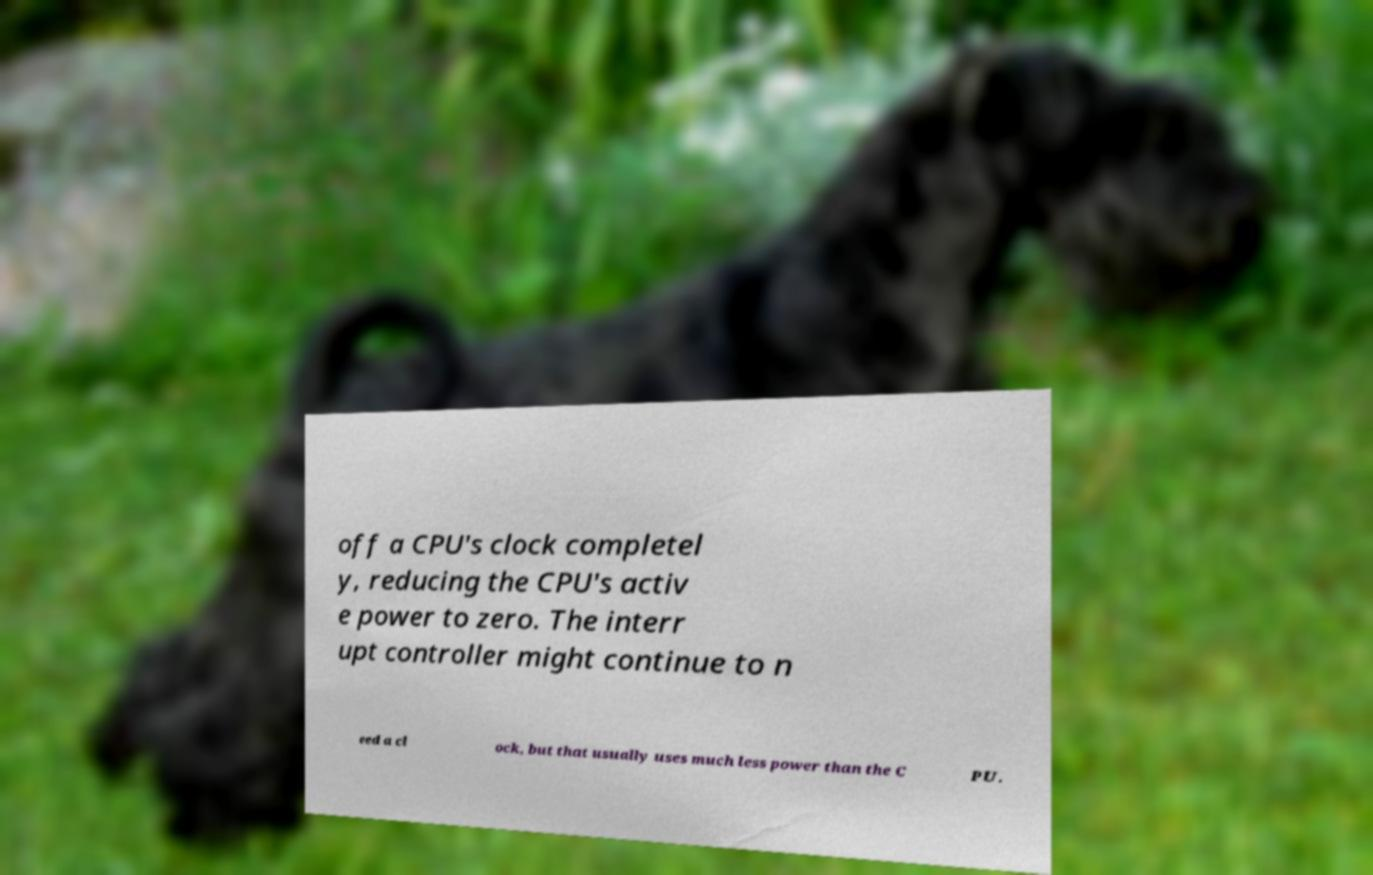What messages or text are displayed in this image? I need them in a readable, typed format. off a CPU's clock completel y, reducing the CPU's activ e power to zero. The interr upt controller might continue to n eed a cl ock, but that usually uses much less power than the C PU. 